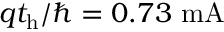<formula> <loc_0><loc_0><loc_500><loc_500>q t _ { h } / \hbar { = } 0 . 7 3 m A</formula> 